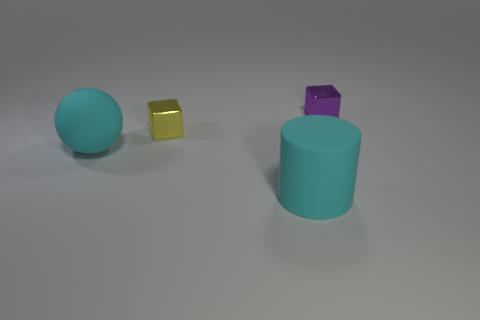Add 2 big gray spheres. How many objects exist? 6 Subtract all yellow cubes. How many cubes are left? 1 Add 4 small metallic objects. How many small metallic objects are left? 6 Add 1 tiny yellow things. How many tiny yellow things exist? 2 Subtract 0 brown blocks. How many objects are left? 4 Subtract all cylinders. How many objects are left? 3 Subtract all spheres. Subtract all purple blocks. How many objects are left? 2 